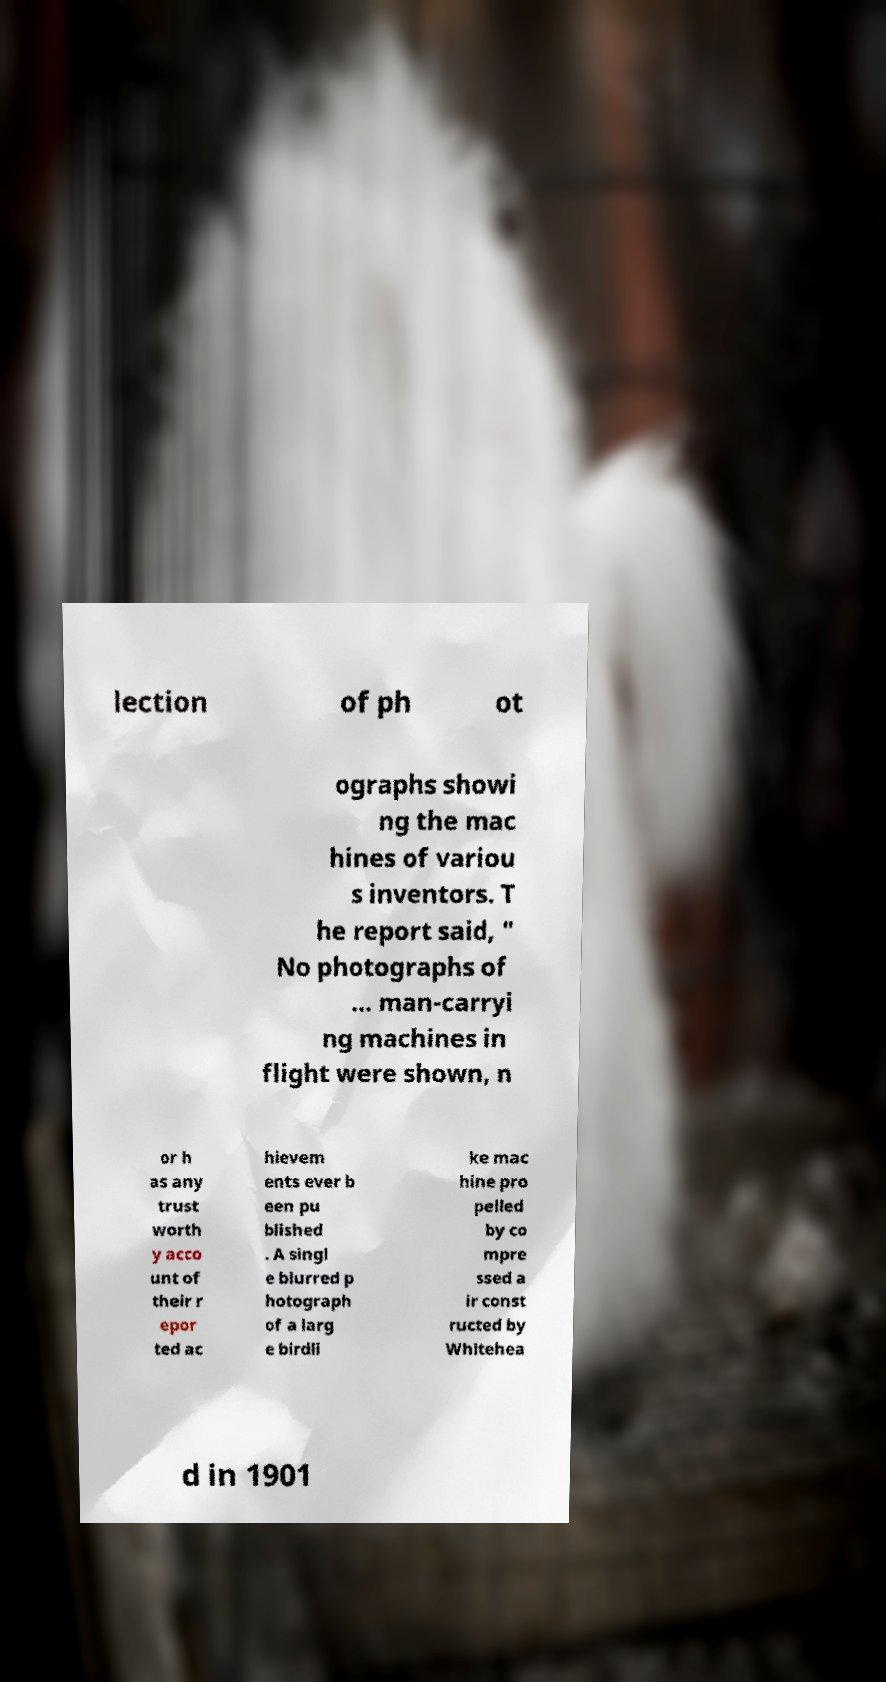There's text embedded in this image that I need extracted. Can you transcribe it verbatim? lection of ph ot ographs showi ng the mac hines of variou s inventors. T he report said, " No photographs of ... man-carryi ng machines in flight were shown, n or h as any trust worth y acco unt of their r epor ted ac hievem ents ever b een pu blished . A singl e blurred p hotograph of a larg e birdli ke mac hine pro pelled by co mpre ssed a ir const ructed by Whitehea d in 1901 